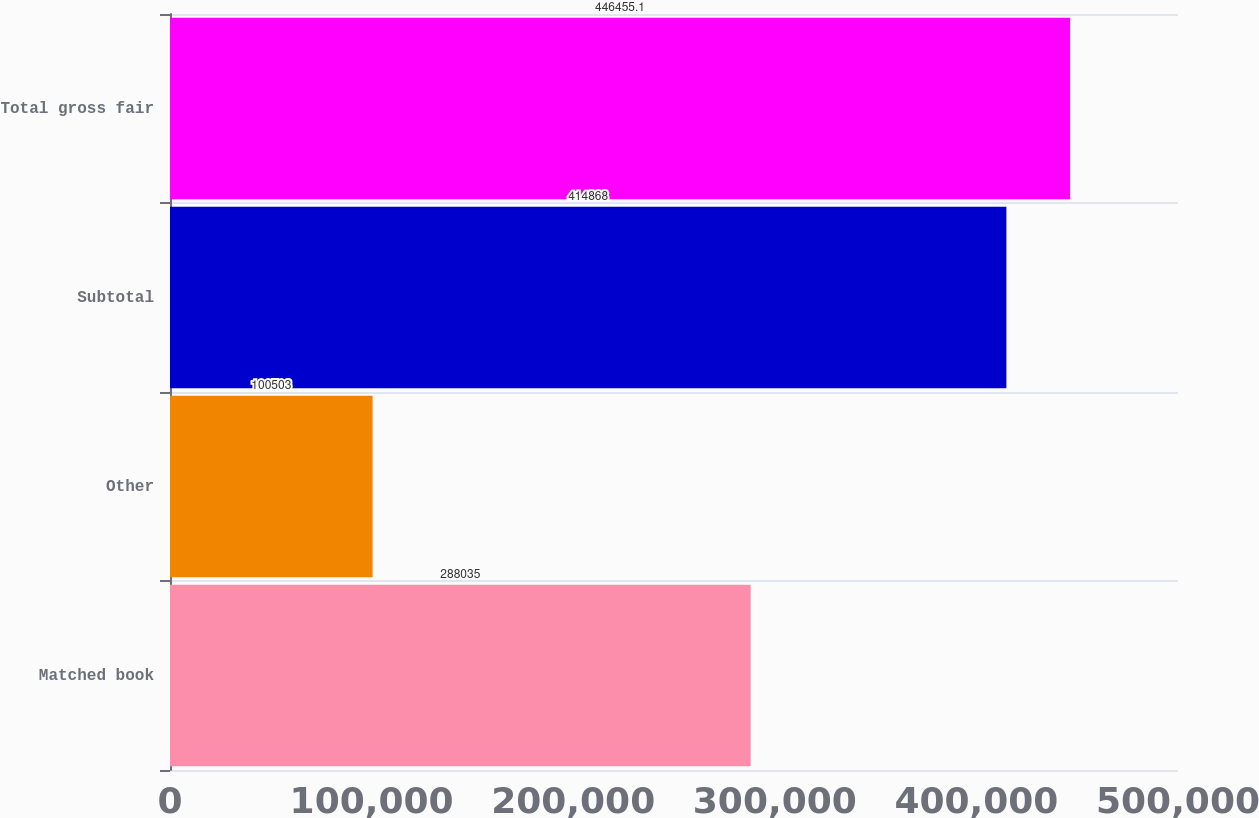Convert chart to OTSL. <chart><loc_0><loc_0><loc_500><loc_500><bar_chart><fcel>Matched book<fcel>Other<fcel>Subtotal<fcel>Total gross fair<nl><fcel>288035<fcel>100503<fcel>414868<fcel>446455<nl></chart> 